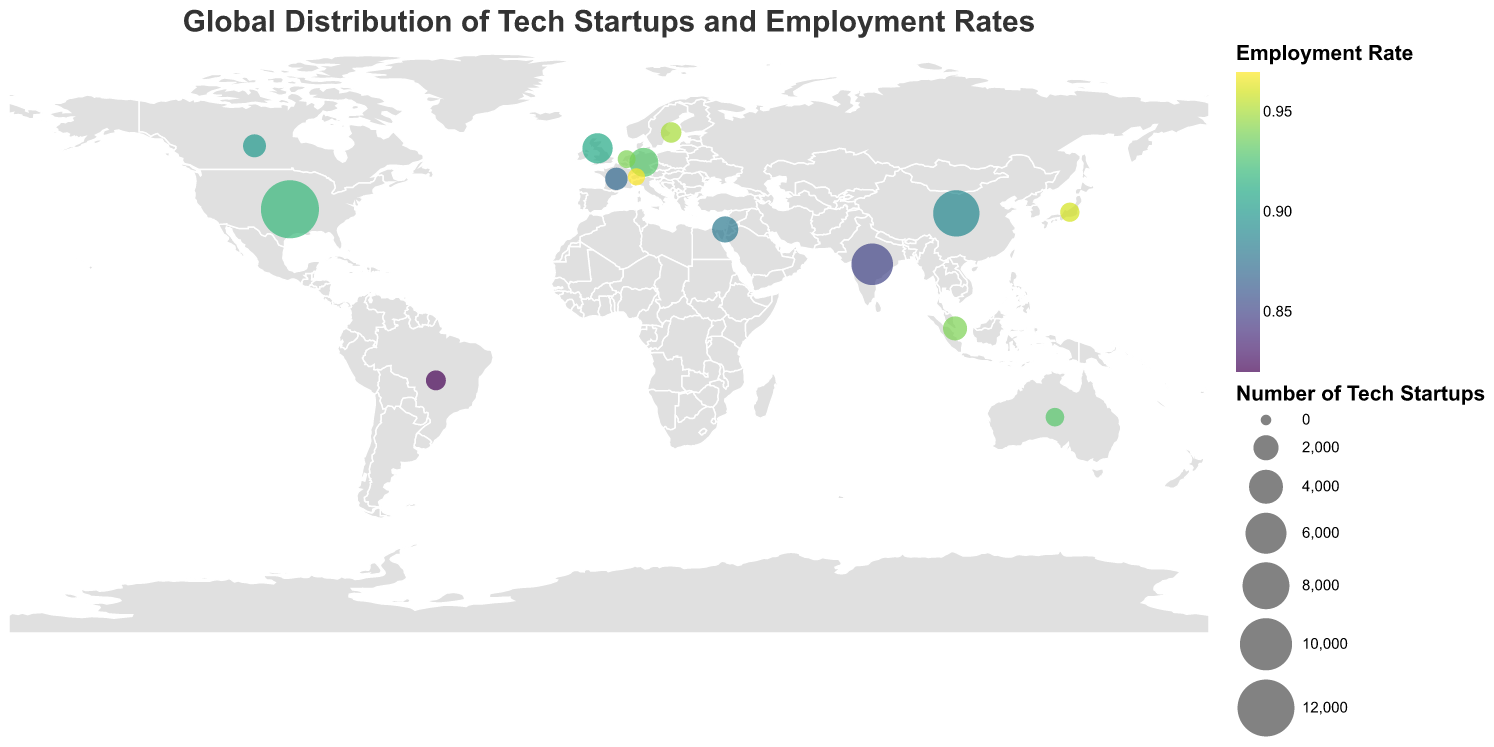What is the title of the plot? The title is displayed at the top-center of the plot. It reads "Global Distribution of Tech Startups and Employment Rates" in Arial font with size 20 and a dark gray color.
Answer: Global Distribution of Tech Startups and Employment Rates Which country has the highest employment rate? By looking at the color gradients on the circles representing employment rates, the country with the most intense color (brightest yellow in this case) has the highest rate. Switzerland has the color that represents the highest employment rate of 0.97.
Answer: Switzerland Which country has the most tech startups? The size of the circles corresponds to the number of tech startups. The largest circle on the plot represents the United States, which has 12,500 tech startups.
Answer: United States Compare the employment rates of Japan and Brazil. Which one is higher, and by how much? By referring to the respective circles' color intensities, the employment rate for Japan is 0.96 and for Brazil is 0.82. Subtracting Brazil's rate from Japan's gives 0.96 - 0.82 = 0.14, indicating that Japan's employment rate is higher by 0.14.
Answer: Japan's employment rate is higher by 0.14 Which country has the smallest number of tech startups? The smallest circle in the plot represents Switzerland, which has 700 tech startups.
Answer: Switzerland What is the average number of tech startups among the countries listed? Sum the number of tech startups for all countries (12500 + 7800 + 6200 + 3100 + 2800 + 2200 + 1800 + 1600 + 1500 + 1200 + 1100 + 1000 + 900 + 800 + 700 = 51000) and divide by the total number of countries (15). 51000 / 15 = 3400.
Answer: 3400 How do the tech startup numbers in China and India compare? China has 7800 tech startups, while India has 6200. Comparing these values, China has 7800 - 6200 = 1600 more tech startups than India.
Answer: China has 1600 more Is there a country with both a high number of tech startups and a high employment rate? By checking both the size and color intensity of the circles, the United States has a high number of tech startups (12500) and a high employment rate (0.92).
Answer: United States Which countries have an employment rate of 0.94 or higher? Identifying the circles with employment rates of 0.94 or higher, the countries are Singapore (0.94), Sweden (0.95), Japan (0.96), Netherlands (0.94), and Switzerland (0.97).
Answer: Singapore, Sweden, Japan, Netherlands, Switzerland 